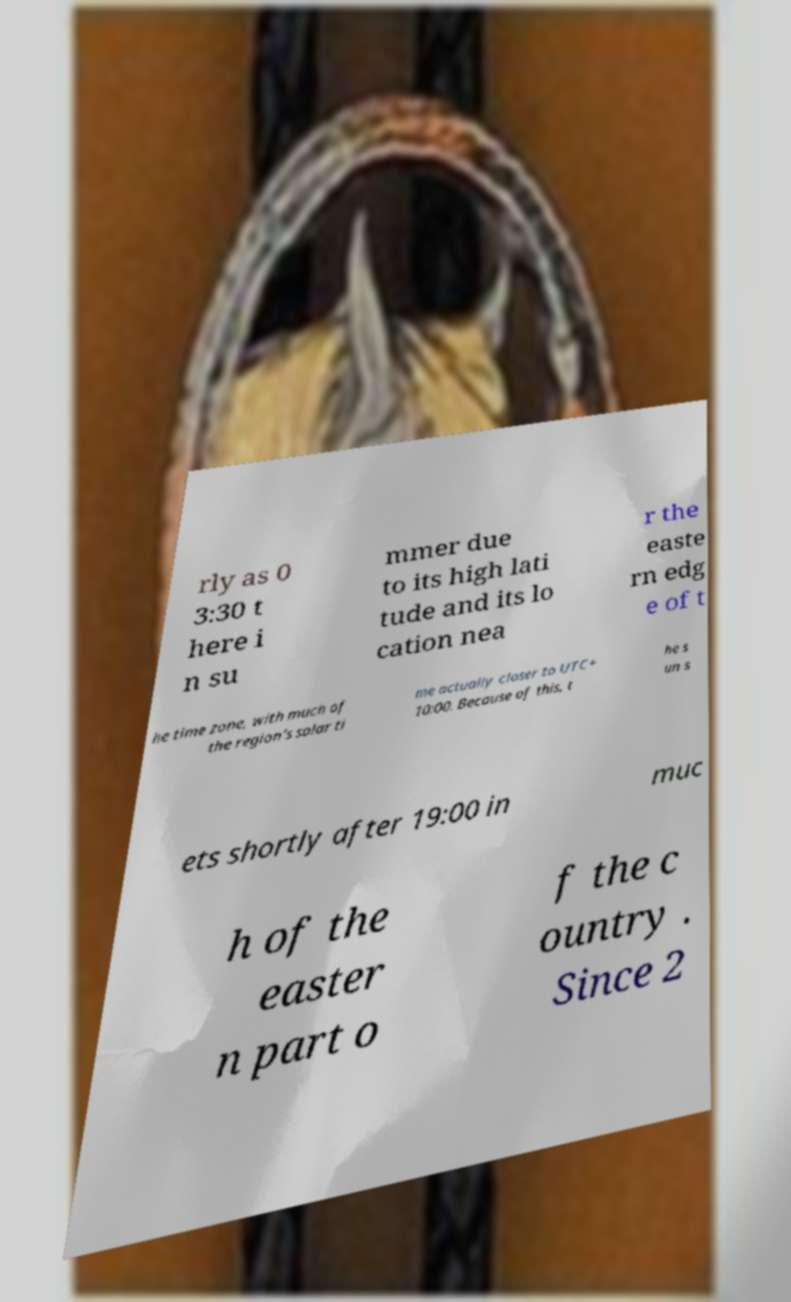Could you extract and type out the text from this image? rly as 0 3:30 t here i n su mmer due to its high lati tude and its lo cation nea r the easte rn edg e of t he time zone, with much of the region's solar ti me actually closer to UTC+ 10:00. Because of this, t he s un s ets shortly after 19:00 in muc h of the easter n part o f the c ountry . Since 2 